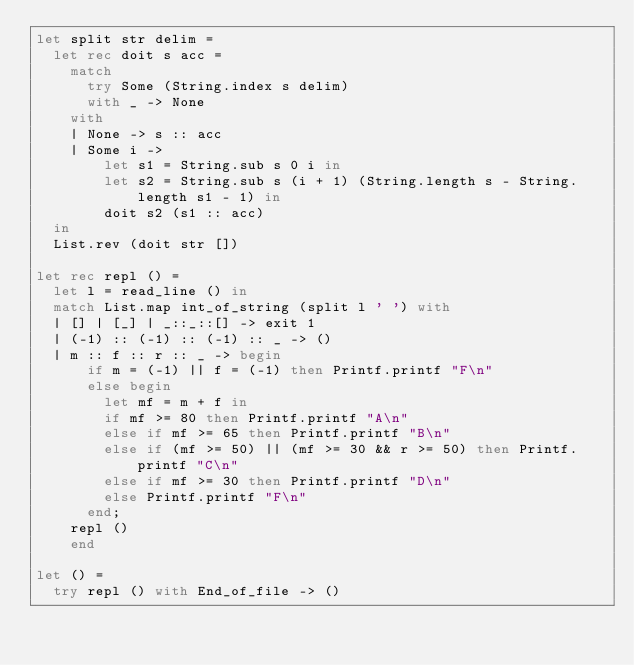<code> <loc_0><loc_0><loc_500><loc_500><_OCaml_>let split str delim =
  let rec doit s acc =
    match
      try Some (String.index s delim)
      with _ -> None
    with
    | None -> s :: acc
    | Some i ->
        let s1 = String.sub s 0 i in
        let s2 = String.sub s (i + 1) (String.length s - String.length s1 - 1) in
        doit s2 (s1 :: acc)
  in
  List.rev (doit str [])

let rec repl () =
  let l = read_line () in
  match List.map int_of_string (split l ' ') with
  | [] | [_] | _::_::[] -> exit 1
  | (-1) :: (-1) :: (-1) :: _ -> ()
  | m :: f :: r :: _ -> begin
      if m = (-1) || f = (-1) then Printf.printf "F\n"
      else begin
        let mf = m + f in
        if mf >= 80 then Printf.printf "A\n"
        else if mf >= 65 then Printf.printf "B\n"
        else if (mf >= 50) || (mf >= 30 && r >= 50) then Printf.printf "C\n"
        else if mf >= 30 then Printf.printf "D\n"
        else Printf.printf "F\n"
      end;
    repl ()
    end

let () =
  try repl () with End_of_file -> ()</code> 